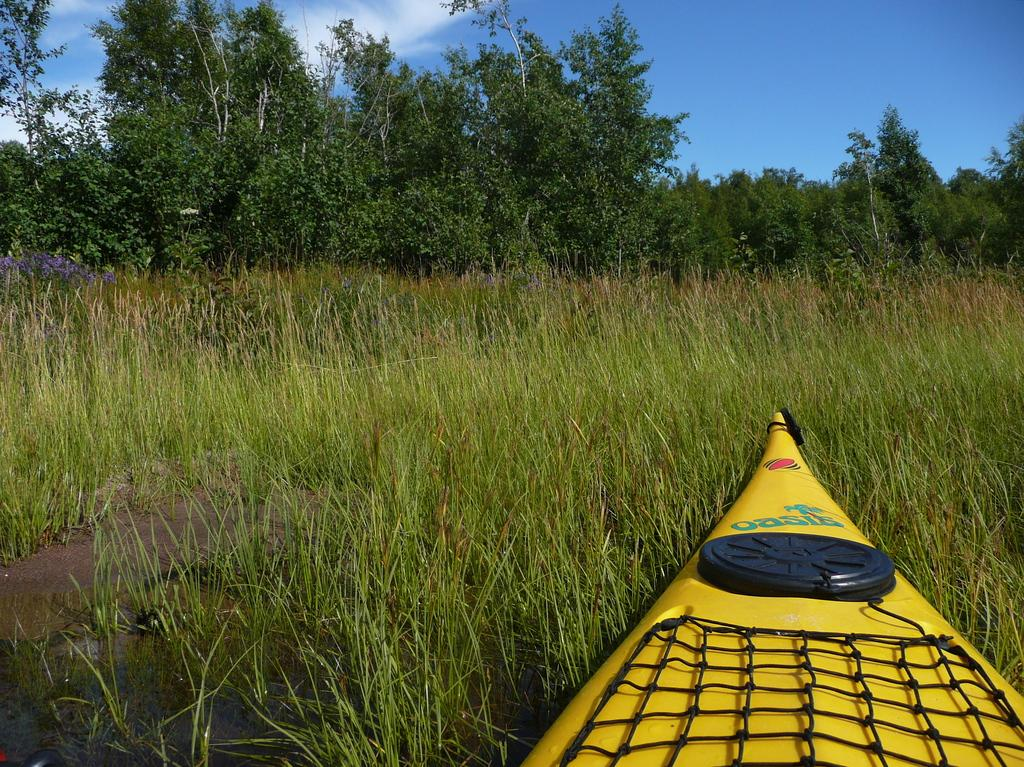What is the main subject in the foreground of the image? There is a boat in the foreground of the image. What can be seen in the background of the image? There is grass, trees, and the sky visible in the background of the image. Are there any clouds in the sky? Yes, there is a cloud in the sky. What type of plastic material can be seen covering the grass in the image? There is no plastic material covering the grass in the image. What does the horse smell like in the image? There is no horse present in the image, so it cannot be determined what it might smell like. 